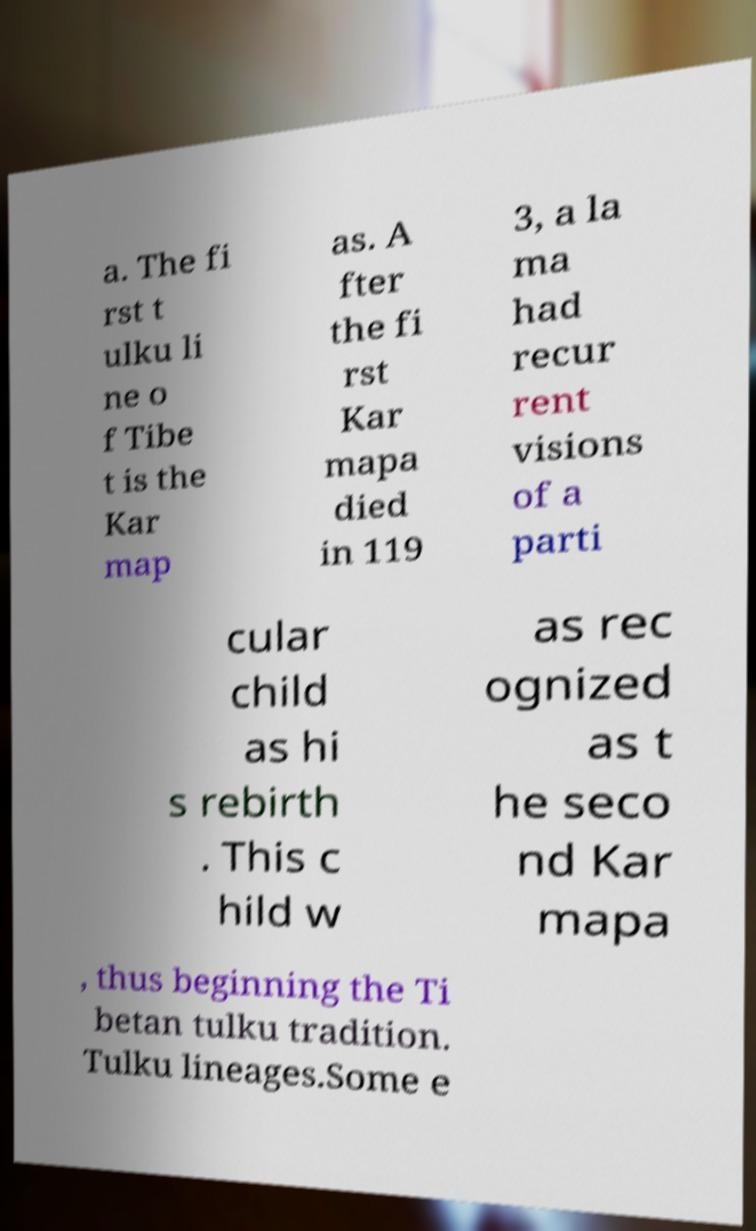Please read and relay the text visible in this image. What does it say? a. The fi rst t ulku li ne o f Tibe t is the Kar map as. A fter the fi rst Kar mapa died in 119 3, a la ma had recur rent visions of a parti cular child as hi s rebirth . This c hild w as rec ognized as t he seco nd Kar mapa , thus beginning the Ti betan tulku tradition. Tulku lineages.Some e 